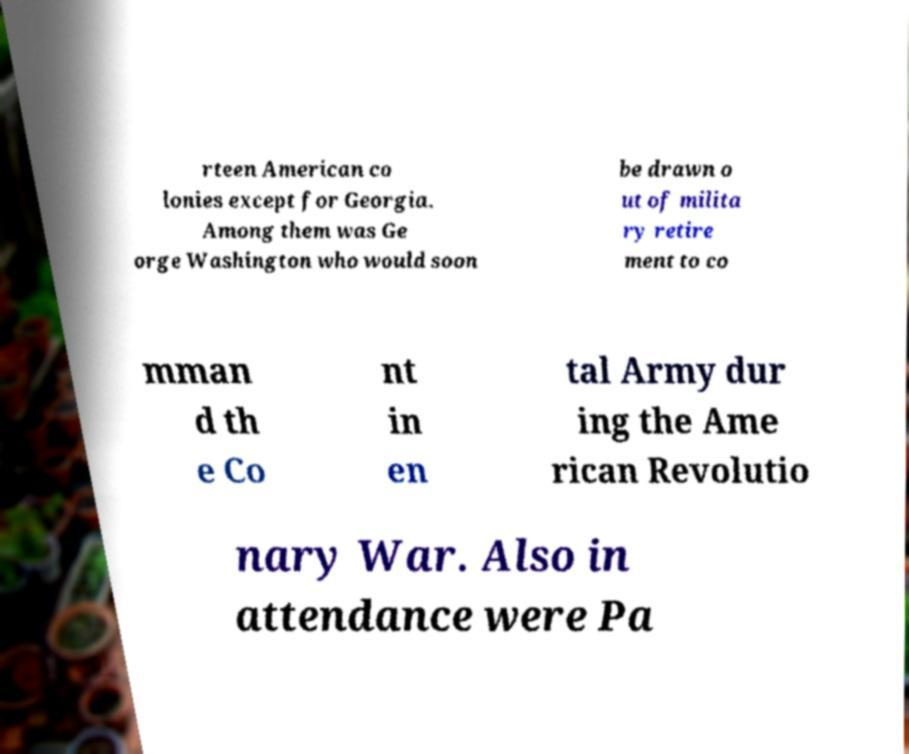Please read and relay the text visible in this image. What does it say? rteen American co lonies except for Georgia. Among them was Ge orge Washington who would soon be drawn o ut of milita ry retire ment to co mman d th e Co nt in en tal Army dur ing the Ame rican Revolutio nary War. Also in attendance were Pa 